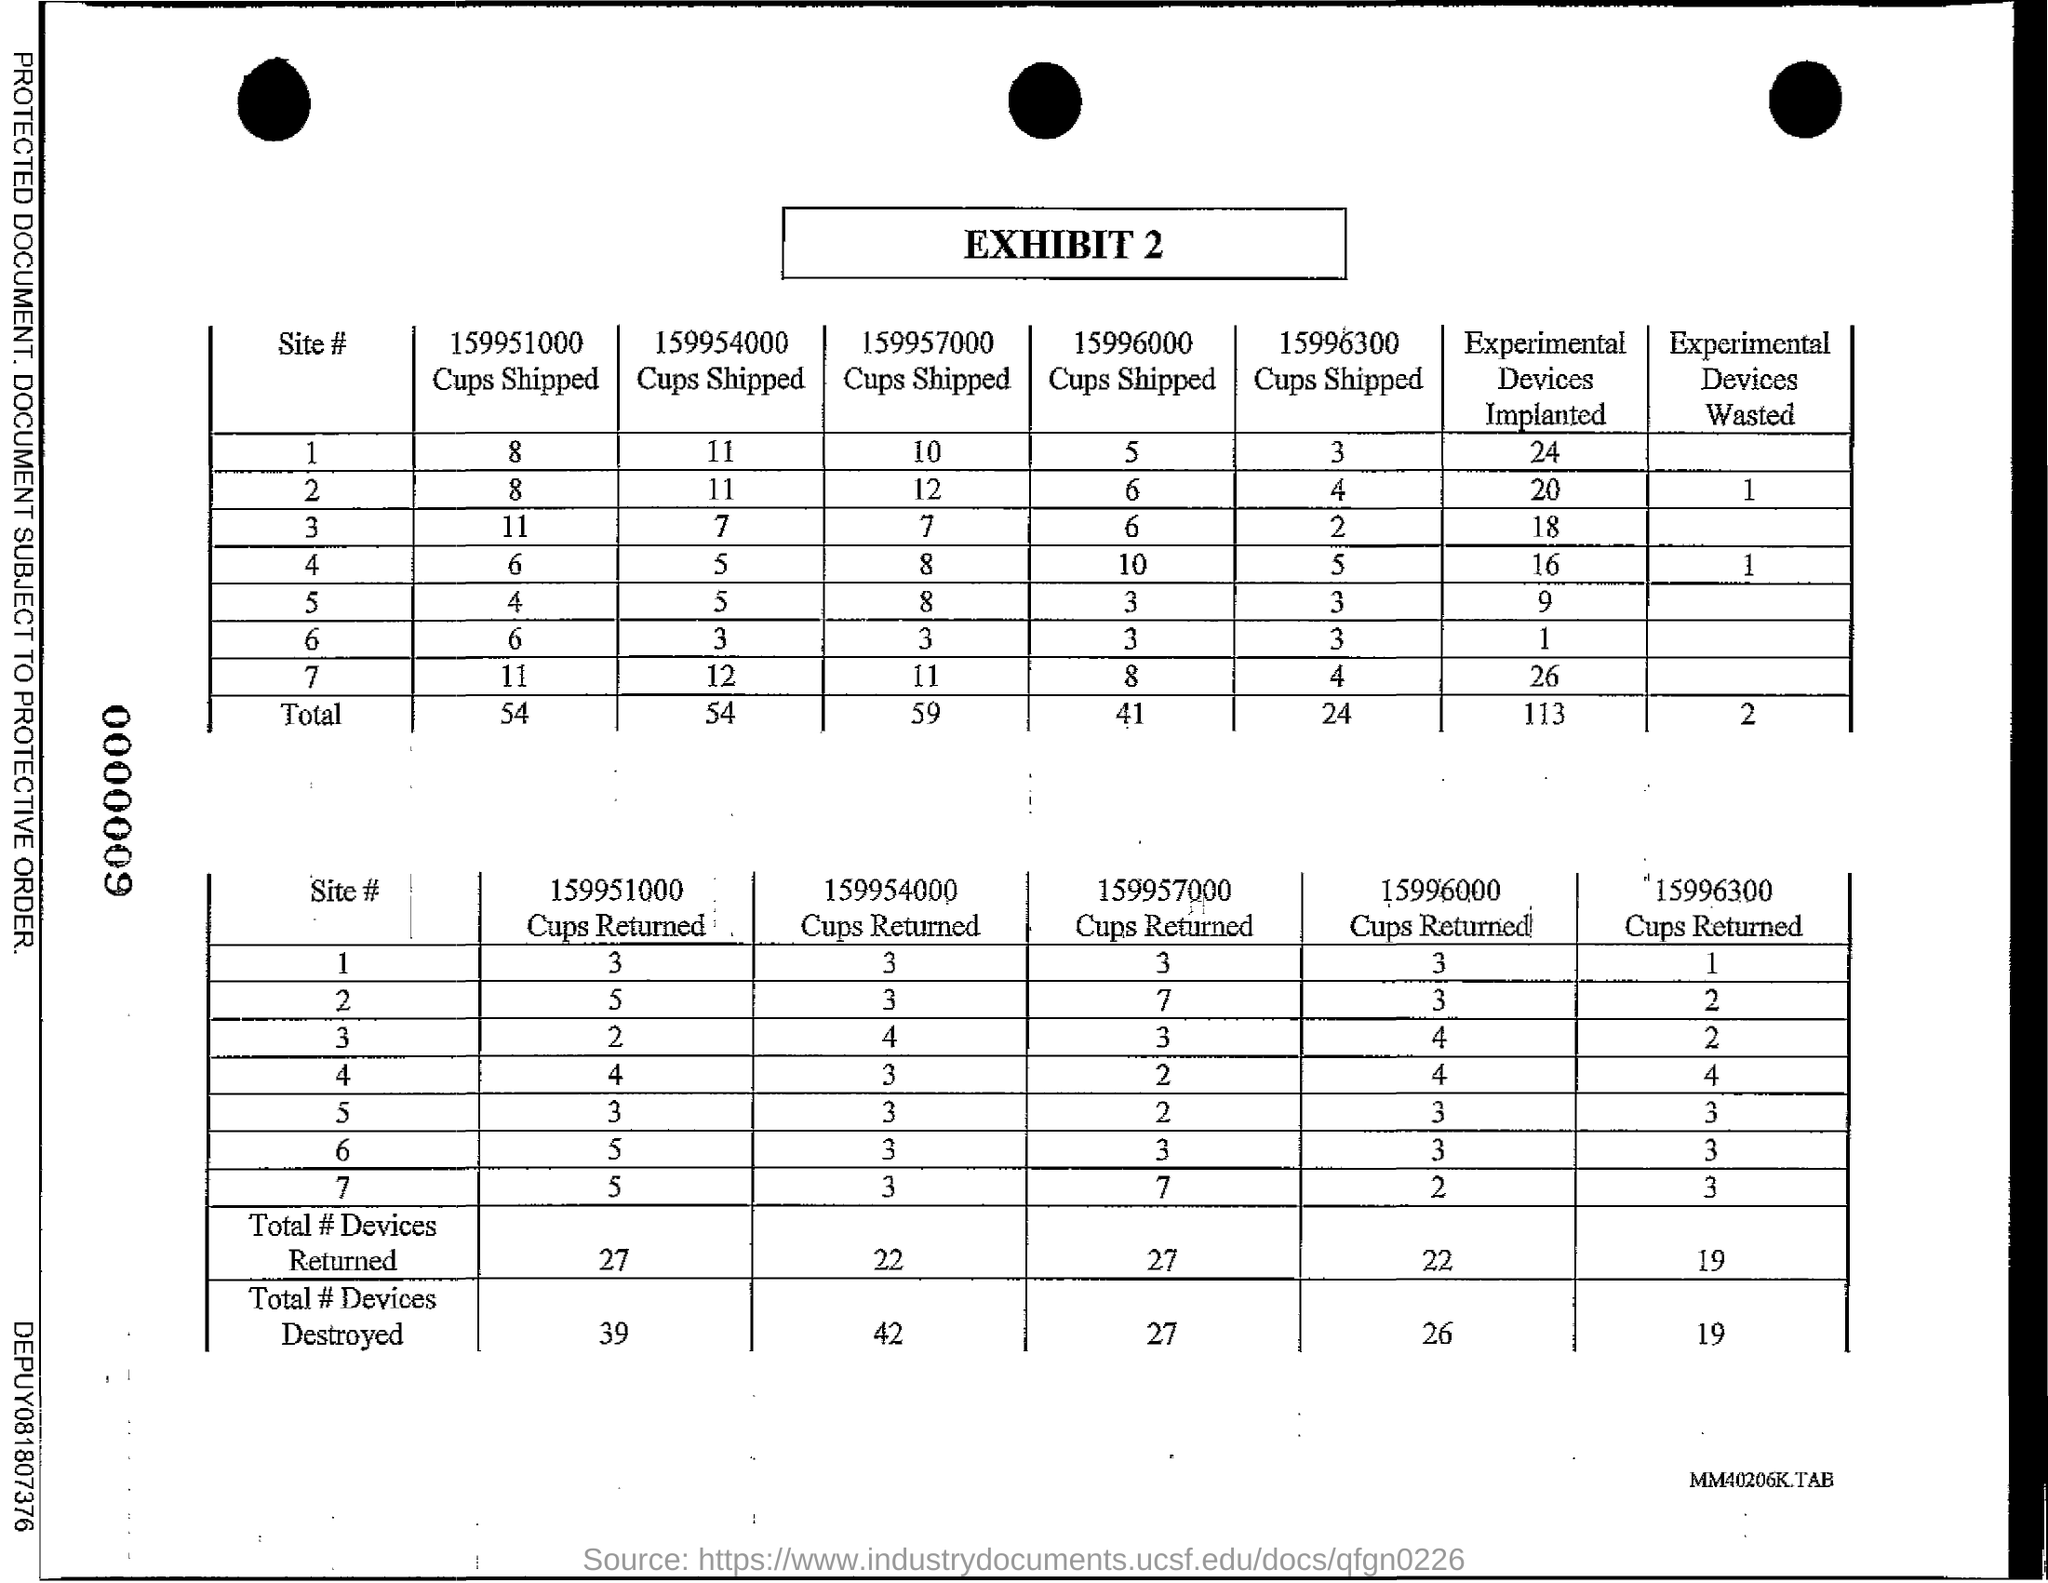What is the Exhibit number?
Your answer should be very brief. 2. 